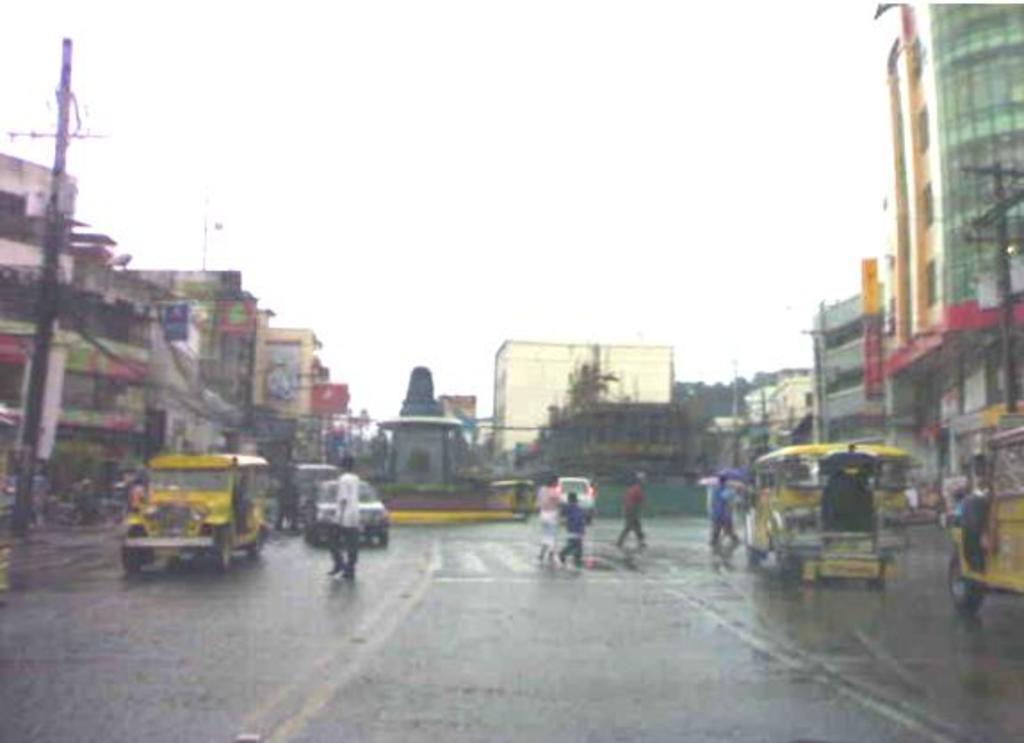Can you describe this image briefly? As we can see in the image there are few people, vehicles, buildings, current poles and trees. At the top there is sky. 